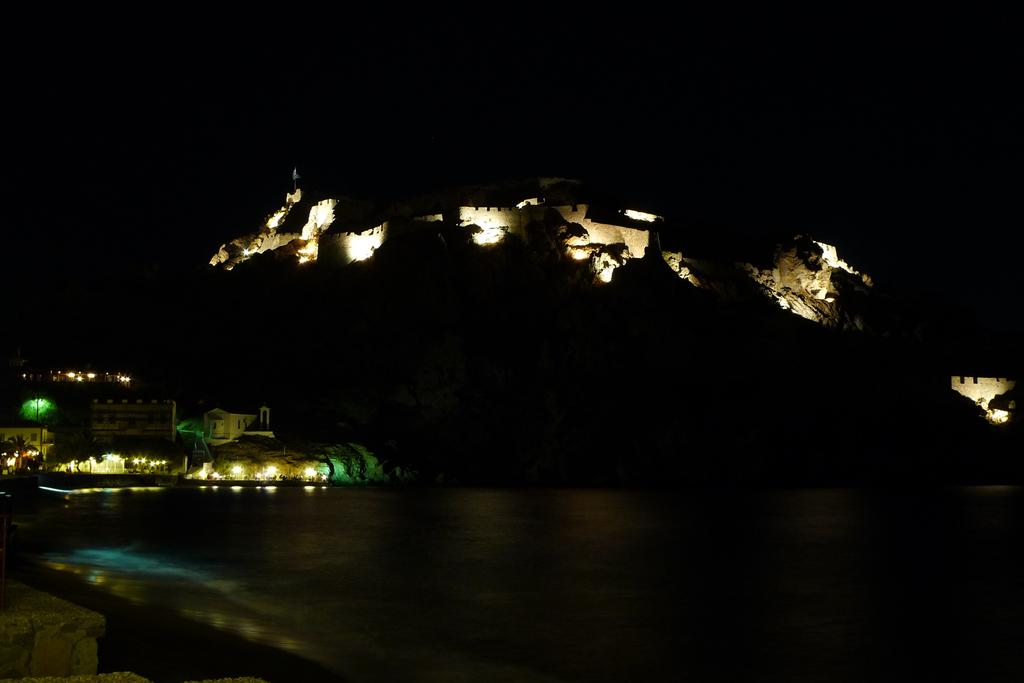What type of structure can be seen in the image? There is a stone structure in the image. What else is visible in the image besides the stone structure? There are buildings in the image. Can you describe the materials used in the stone structure? The stone structure is made of stone, as indicated by the fact. What is present at the bottom of the image? Flour and water are present at the bottom of the image. What type of drink is being served in the office in the image? There is no office or drink present in the image; it features a stone structure and buildings. 